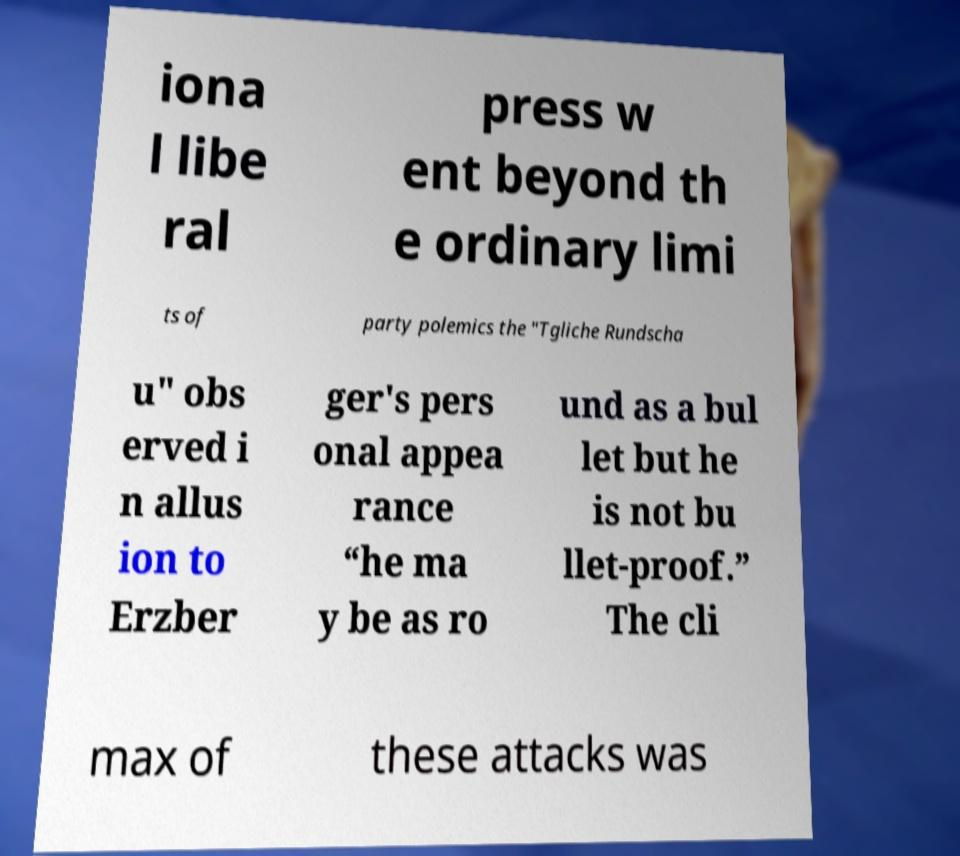Can you read and provide the text displayed in the image?This photo seems to have some interesting text. Can you extract and type it out for me? iona l libe ral press w ent beyond th e ordinary limi ts of party polemics the "Tgliche Rundscha u" obs erved i n allus ion to Erzber ger's pers onal appea rance “he ma y be as ro und as a bul let but he is not bu llet-proof.” The cli max of these attacks was 